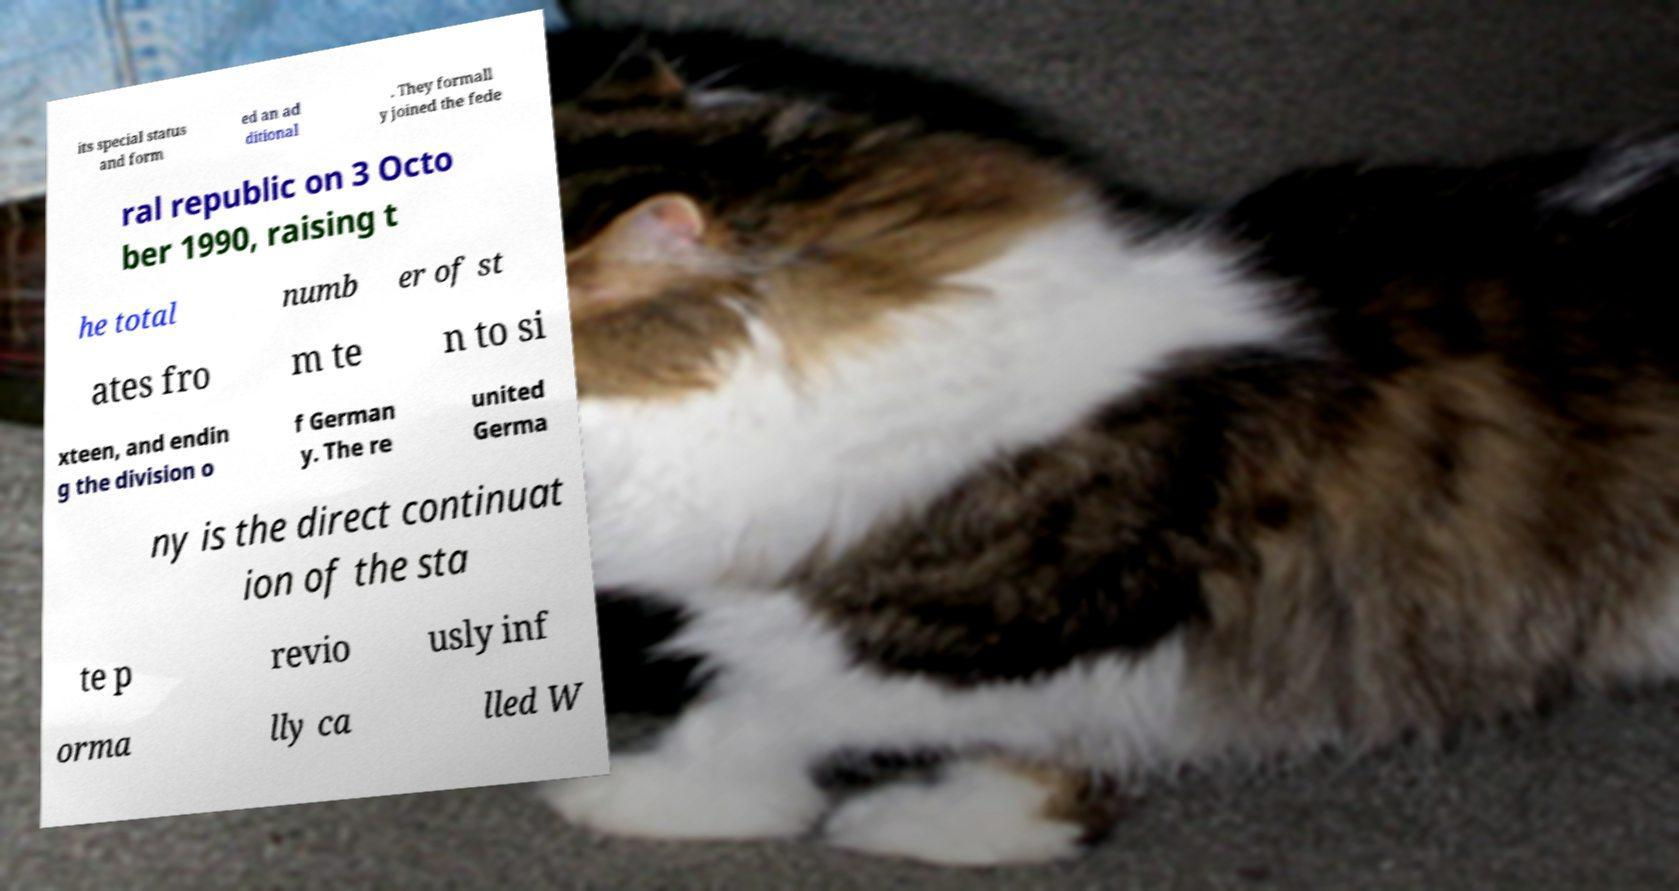Please read and relay the text visible in this image. What does it say? its special status and form ed an ad ditional . They formall y joined the fede ral republic on 3 Octo ber 1990, raising t he total numb er of st ates fro m te n to si xteen, and endin g the division o f German y. The re united Germa ny is the direct continuat ion of the sta te p revio usly inf orma lly ca lled W 